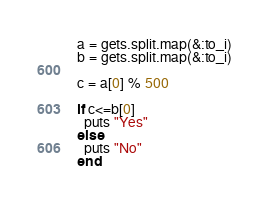<code> <loc_0><loc_0><loc_500><loc_500><_Ruby_>a = gets.split.map(&:to_i)
b = gets.split.map(&:to_i)

c = a[0] % 500

if c<=b[0]
  puts "Yes"
else
  puts "No"
end</code> 